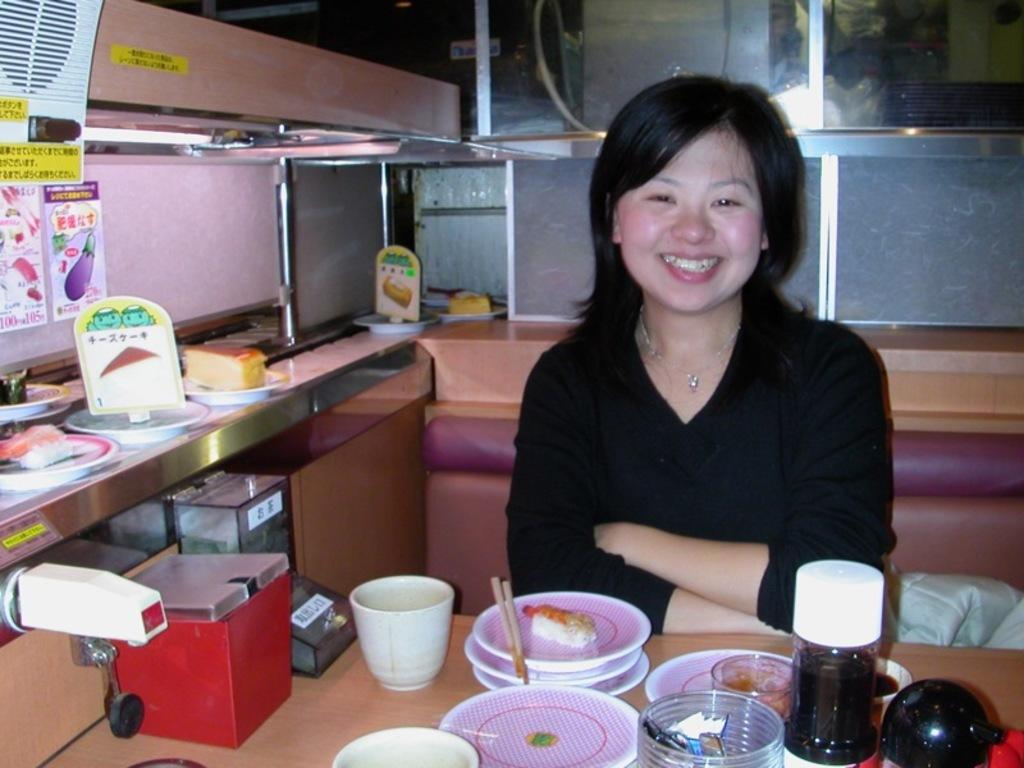In one or two sentences, can you explain what this image depicts? There is a woman sitting in the chair and smiling in front of a table on which some plates, glasses, bottles were placed. In the background there is a window. To the left side there are some food items were placed. 